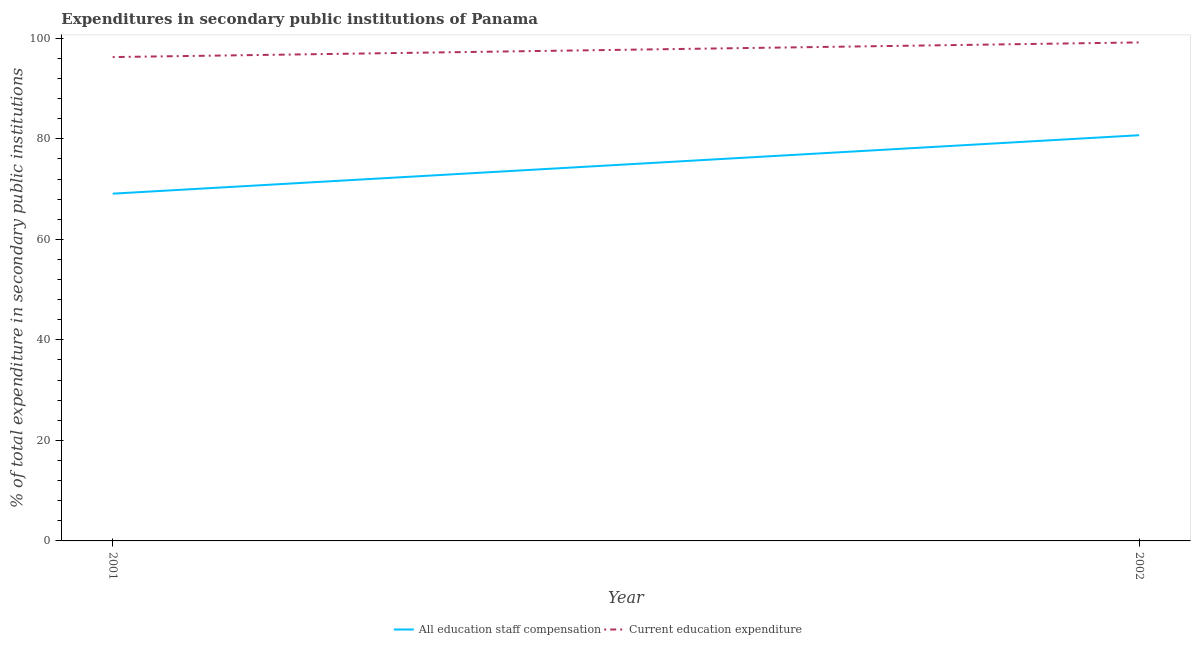Is the number of lines equal to the number of legend labels?
Give a very brief answer. Yes. What is the expenditure in staff compensation in 2002?
Provide a succinct answer. 80.71. Across all years, what is the maximum expenditure in education?
Your answer should be very brief. 99.17. Across all years, what is the minimum expenditure in staff compensation?
Provide a succinct answer. 69.09. In which year was the expenditure in education maximum?
Offer a very short reply. 2002. What is the total expenditure in staff compensation in the graph?
Your answer should be very brief. 149.8. What is the difference between the expenditure in education in 2001 and that in 2002?
Provide a succinct answer. -2.91. What is the difference between the expenditure in staff compensation in 2002 and the expenditure in education in 2001?
Your answer should be very brief. -15.55. What is the average expenditure in education per year?
Make the answer very short. 97.72. In the year 2002, what is the difference between the expenditure in staff compensation and expenditure in education?
Your answer should be compact. -18.46. What is the ratio of the expenditure in education in 2001 to that in 2002?
Your response must be concise. 0.97. Is the expenditure in education in 2001 less than that in 2002?
Offer a very short reply. Yes. Does the expenditure in education monotonically increase over the years?
Offer a terse response. Yes. Is the expenditure in education strictly greater than the expenditure in staff compensation over the years?
Give a very brief answer. Yes. Is the expenditure in education strictly less than the expenditure in staff compensation over the years?
Keep it short and to the point. No. How many lines are there?
Make the answer very short. 2. How many years are there in the graph?
Provide a succinct answer. 2. What is the difference between two consecutive major ticks on the Y-axis?
Keep it short and to the point. 20. Where does the legend appear in the graph?
Keep it short and to the point. Bottom center. What is the title of the graph?
Your answer should be compact. Expenditures in secondary public institutions of Panama. Does "All education staff compensation" appear as one of the legend labels in the graph?
Ensure brevity in your answer.  Yes. What is the label or title of the Y-axis?
Offer a very short reply. % of total expenditure in secondary public institutions. What is the % of total expenditure in secondary public institutions of All education staff compensation in 2001?
Keep it short and to the point. 69.09. What is the % of total expenditure in secondary public institutions in Current education expenditure in 2001?
Your answer should be very brief. 96.26. What is the % of total expenditure in secondary public institutions in All education staff compensation in 2002?
Make the answer very short. 80.71. What is the % of total expenditure in secondary public institutions of Current education expenditure in 2002?
Your answer should be compact. 99.17. Across all years, what is the maximum % of total expenditure in secondary public institutions in All education staff compensation?
Offer a terse response. 80.71. Across all years, what is the maximum % of total expenditure in secondary public institutions in Current education expenditure?
Provide a short and direct response. 99.17. Across all years, what is the minimum % of total expenditure in secondary public institutions of All education staff compensation?
Your response must be concise. 69.09. Across all years, what is the minimum % of total expenditure in secondary public institutions of Current education expenditure?
Ensure brevity in your answer.  96.26. What is the total % of total expenditure in secondary public institutions in All education staff compensation in the graph?
Offer a very short reply. 149.8. What is the total % of total expenditure in secondary public institutions in Current education expenditure in the graph?
Your answer should be compact. 195.43. What is the difference between the % of total expenditure in secondary public institutions in All education staff compensation in 2001 and that in 2002?
Provide a short and direct response. -11.63. What is the difference between the % of total expenditure in secondary public institutions of Current education expenditure in 2001 and that in 2002?
Your answer should be compact. -2.91. What is the difference between the % of total expenditure in secondary public institutions of All education staff compensation in 2001 and the % of total expenditure in secondary public institutions of Current education expenditure in 2002?
Give a very brief answer. -30.09. What is the average % of total expenditure in secondary public institutions in All education staff compensation per year?
Your response must be concise. 74.9. What is the average % of total expenditure in secondary public institutions of Current education expenditure per year?
Make the answer very short. 97.72. In the year 2001, what is the difference between the % of total expenditure in secondary public institutions of All education staff compensation and % of total expenditure in secondary public institutions of Current education expenditure?
Your answer should be very brief. -27.17. In the year 2002, what is the difference between the % of total expenditure in secondary public institutions of All education staff compensation and % of total expenditure in secondary public institutions of Current education expenditure?
Ensure brevity in your answer.  -18.46. What is the ratio of the % of total expenditure in secondary public institutions of All education staff compensation in 2001 to that in 2002?
Your response must be concise. 0.86. What is the ratio of the % of total expenditure in secondary public institutions in Current education expenditure in 2001 to that in 2002?
Ensure brevity in your answer.  0.97. What is the difference between the highest and the second highest % of total expenditure in secondary public institutions of All education staff compensation?
Keep it short and to the point. 11.63. What is the difference between the highest and the second highest % of total expenditure in secondary public institutions in Current education expenditure?
Provide a succinct answer. 2.91. What is the difference between the highest and the lowest % of total expenditure in secondary public institutions of All education staff compensation?
Your answer should be compact. 11.63. What is the difference between the highest and the lowest % of total expenditure in secondary public institutions in Current education expenditure?
Your response must be concise. 2.91. 